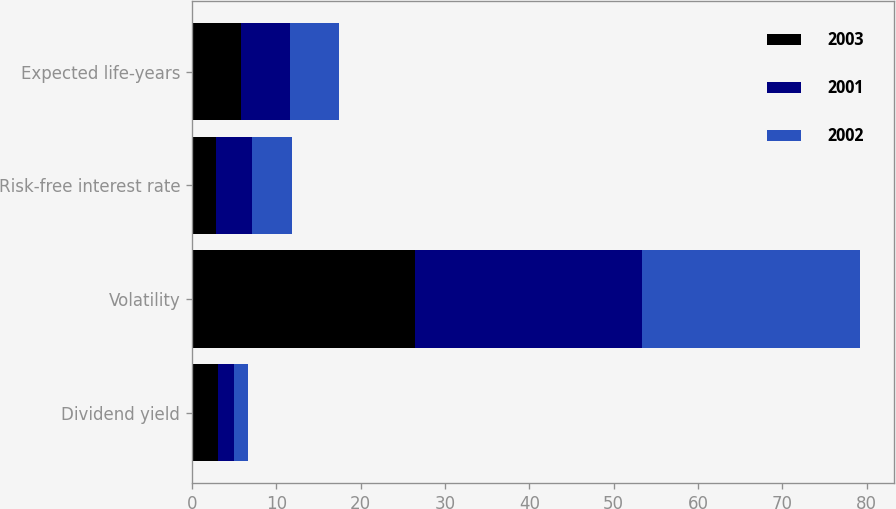<chart> <loc_0><loc_0><loc_500><loc_500><stacked_bar_chart><ecel><fcel>Dividend yield<fcel>Volatility<fcel>Risk-free interest rate<fcel>Expected life-years<nl><fcel>2003<fcel>3.05<fcel>26.49<fcel>2.83<fcel>5.8<nl><fcel>2001<fcel>1.97<fcel>26.91<fcel>4.3<fcel>5.8<nl><fcel>2002<fcel>1.61<fcel>25.86<fcel>4.7<fcel>5.8<nl></chart> 